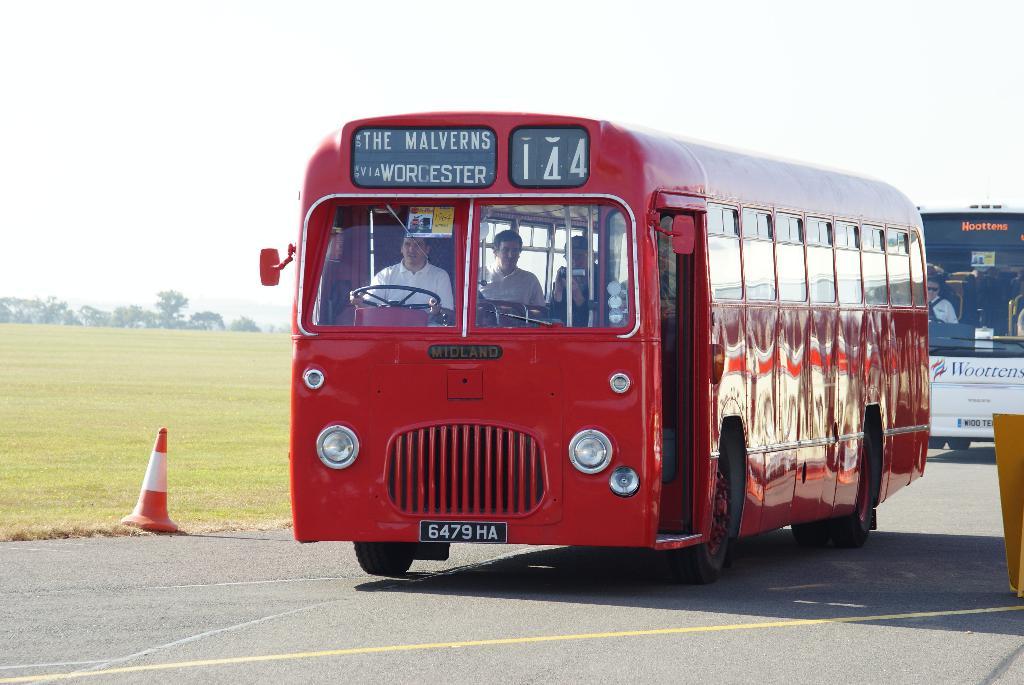What bus route number is this?
Offer a terse response. 144. 